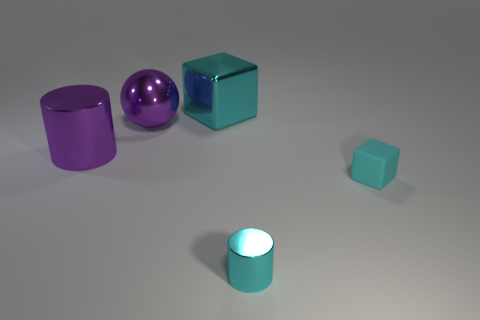Is the number of large cyan shiny objects greater than the number of gray spheres?
Provide a short and direct response. Yes. The cylinder that is on the right side of the large cyan metallic thing is what color?
Provide a succinct answer. Cyan. What size is the metallic object that is in front of the big purple metal ball and left of the small shiny cylinder?
Provide a short and direct response. Large. How many things have the same size as the matte cube?
Offer a terse response. 1. There is another purple object that is the same shape as the tiny metal thing; what is it made of?
Give a very brief answer. Metal. Does the tiny cyan metallic object have the same shape as the small cyan matte object?
Your answer should be compact. No. There is a small cyan cylinder; what number of cyan matte cubes are in front of it?
Your answer should be very brief. 0. There is a big cyan thing that is on the right side of the large metal sphere that is to the left of the tiny cylinder; what is its shape?
Your answer should be compact. Cube. There is a cyan object that is made of the same material as the tiny cyan cylinder; what is its shape?
Your response must be concise. Cube. There is a shiny thing on the right side of the cyan metal cube; does it have the same size as the shiny cylinder that is left of the large shiny block?
Offer a terse response. No. 